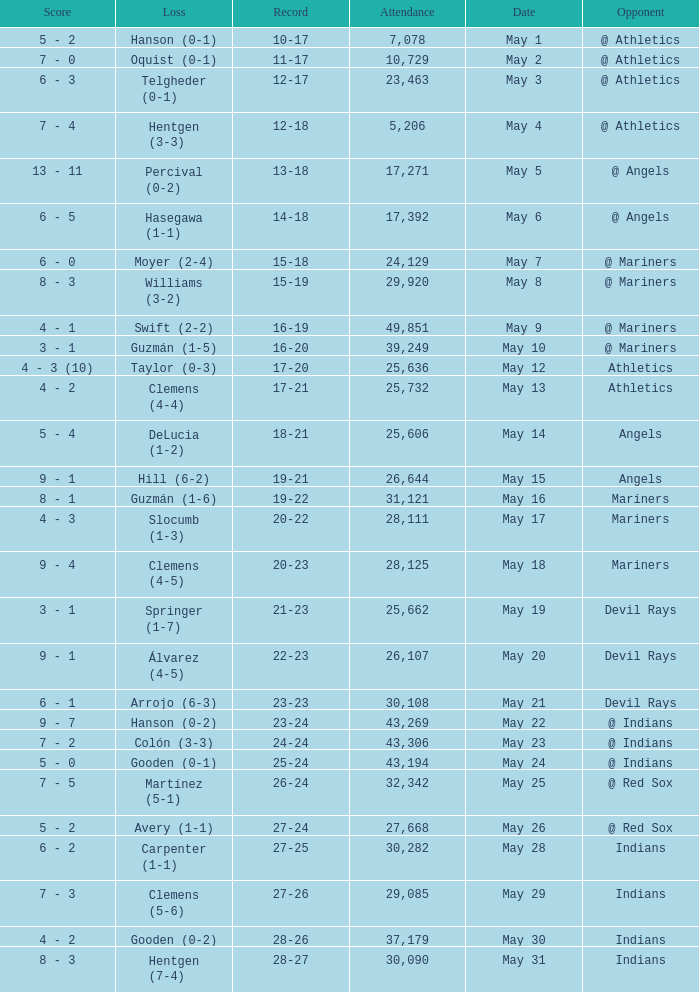Who lost on May 31? Hentgen (7-4). 